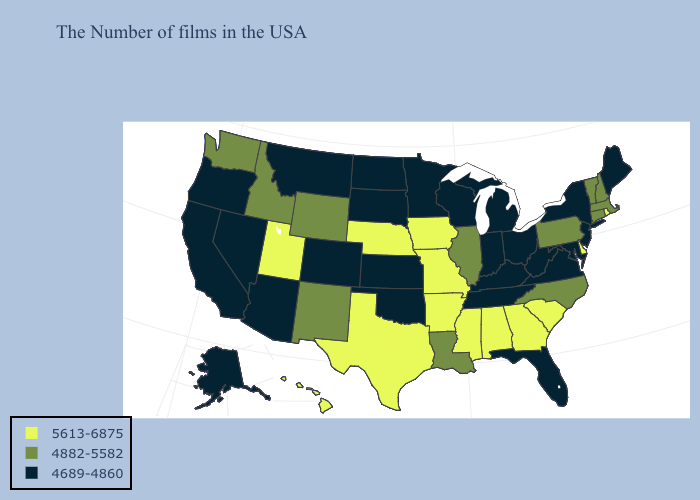What is the value of Virginia?
Short answer required. 4689-4860. Does Pennsylvania have the lowest value in the Northeast?
Quick response, please. No. Name the states that have a value in the range 5613-6875?
Short answer required. Rhode Island, Delaware, South Carolina, Georgia, Alabama, Mississippi, Missouri, Arkansas, Iowa, Nebraska, Texas, Utah, Hawaii. Which states have the lowest value in the USA?
Keep it brief. Maine, New York, New Jersey, Maryland, Virginia, West Virginia, Ohio, Florida, Michigan, Kentucky, Indiana, Tennessee, Wisconsin, Minnesota, Kansas, Oklahoma, South Dakota, North Dakota, Colorado, Montana, Arizona, Nevada, California, Oregon, Alaska. What is the lowest value in the South?
Keep it brief. 4689-4860. What is the value of Utah?
Give a very brief answer. 5613-6875. What is the value of South Carolina?
Give a very brief answer. 5613-6875. Name the states that have a value in the range 4882-5582?
Be succinct. Massachusetts, New Hampshire, Vermont, Connecticut, Pennsylvania, North Carolina, Illinois, Louisiana, Wyoming, New Mexico, Idaho, Washington. Among the states that border South Carolina , does Georgia have the highest value?
Keep it brief. Yes. Is the legend a continuous bar?
Concise answer only. No. Name the states that have a value in the range 4882-5582?
Keep it brief. Massachusetts, New Hampshire, Vermont, Connecticut, Pennsylvania, North Carolina, Illinois, Louisiana, Wyoming, New Mexico, Idaho, Washington. Name the states that have a value in the range 4689-4860?
Short answer required. Maine, New York, New Jersey, Maryland, Virginia, West Virginia, Ohio, Florida, Michigan, Kentucky, Indiana, Tennessee, Wisconsin, Minnesota, Kansas, Oklahoma, South Dakota, North Dakota, Colorado, Montana, Arizona, Nevada, California, Oregon, Alaska. Name the states that have a value in the range 5613-6875?
Concise answer only. Rhode Island, Delaware, South Carolina, Georgia, Alabama, Mississippi, Missouri, Arkansas, Iowa, Nebraska, Texas, Utah, Hawaii. Name the states that have a value in the range 4882-5582?
Write a very short answer. Massachusetts, New Hampshire, Vermont, Connecticut, Pennsylvania, North Carolina, Illinois, Louisiana, Wyoming, New Mexico, Idaho, Washington. Which states have the lowest value in the MidWest?
Short answer required. Ohio, Michigan, Indiana, Wisconsin, Minnesota, Kansas, South Dakota, North Dakota. 